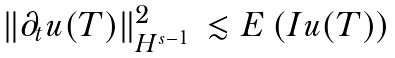<formula> <loc_0><loc_0><loc_500><loc_500>\begin{array} { l l } \| \partial _ { t } u ( T ) \| ^ { 2 } _ { H ^ { s - 1 } } & \lesssim E \left ( I u ( T ) \right ) \end{array}</formula> 